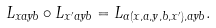Convert formula to latex. <formula><loc_0><loc_0><loc_500><loc_500>L _ { x a y b } \circ L _ { x ^ { \prime } a y b } = L _ { \Gamma ( x , a , y , b , x ^ { \prime } ) , a y b } .</formula> 